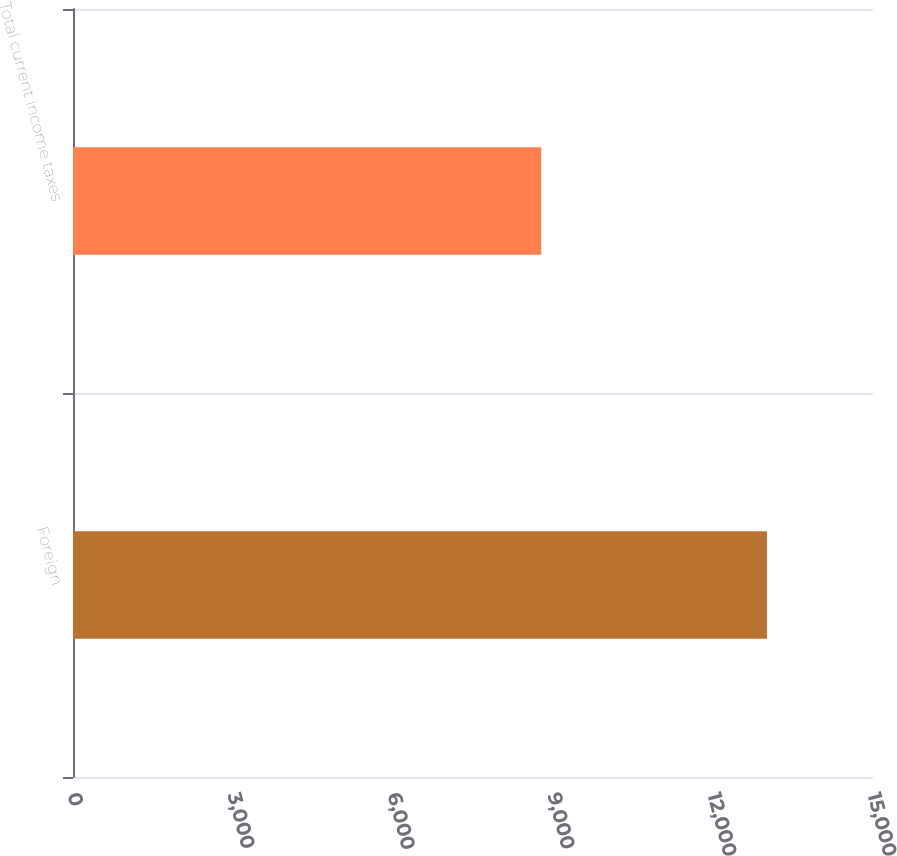Convert chart to OTSL. <chart><loc_0><loc_0><loc_500><loc_500><bar_chart><fcel>Foreign<fcel>Total current income taxes<nl><fcel>13012<fcel>8780<nl></chart> 